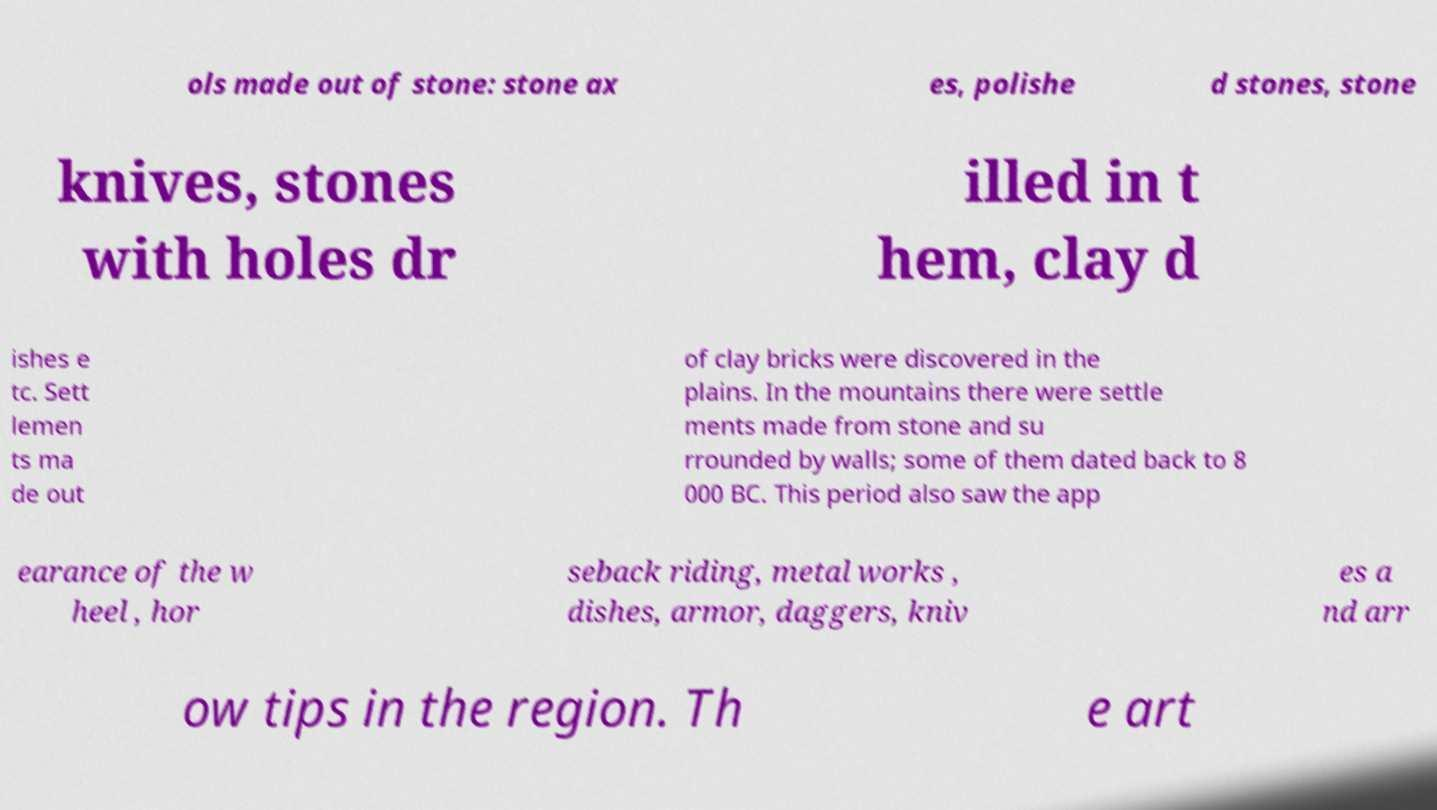Please read and relay the text visible in this image. What does it say? ols made out of stone: stone ax es, polishe d stones, stone knives, stones with holes dr illed in t hem, clay d ishes e tc. Sett lemen ts ma de out of clay bricks were discovered in the plains. In the mountains there were settle ments made from stone and su rrounded by walls; some of them dated back to 8 000 BC. This period also saw the app earance of the w heel , hor seback riding, metal works , dishes, armor, daggers, kniv es a nd arr ow tips in the region. Th e art 